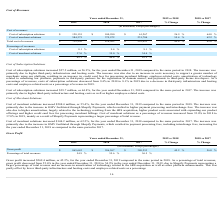According to Shopify's financial document, What is the gross profit as at year ended December 31, 2019? According to the financial document, $ 865,643 (in thousands). The relevant text states: "Gross profit $ 865,643 $ 596,267 $ 380,253 45.2 % 56.8 %..." Also, What is the gross profit as at year ended December 31, 2018? According to the financial document, $ 596,267 (in thousands). The relevant text states: "Gross profit $ 865,643 $ 596,267 $ 380,253 45.2 % 56.8 %..." Also, What is the gross profit as at year ended December 31, 2017? According to the financial document, $ 380,253 (in thousands). The relevant text states: "Gross profit $ 865,643 $ 596,267 $ 380,253 45.2 % 56.8 %..." Additionally, Between year ended 2018 and 2019, which year had higher gross profit? According to the financial document, 2019. The relevant text states: "Years ended December 31, 2019 vs 2018 2018 vs 2017..." Additionally, Between year ended 2017 and 2018, which year had higher gross profit? According to the financial document, 2018. The relevant text states: "Years ended December 31, 2019 vs 2018 2018 vs 2017..." Also, can you calculate: What is the average gross profit for 2018 and 2019? To answer this question, I need to perform calculations using the financial data. The calculation is: (865,643+596,267)/2, which equals 730955 (in thousands). This is based on the information: "Gross profit $ 865,643 $ 596,267 $ 380,253 45.2 % 56.8 % Gross profit $ 865,643 $ 596,267 $ 380,253 45.2 % 56.8 %..." The key data points involved are: 596,267, 865,643. 